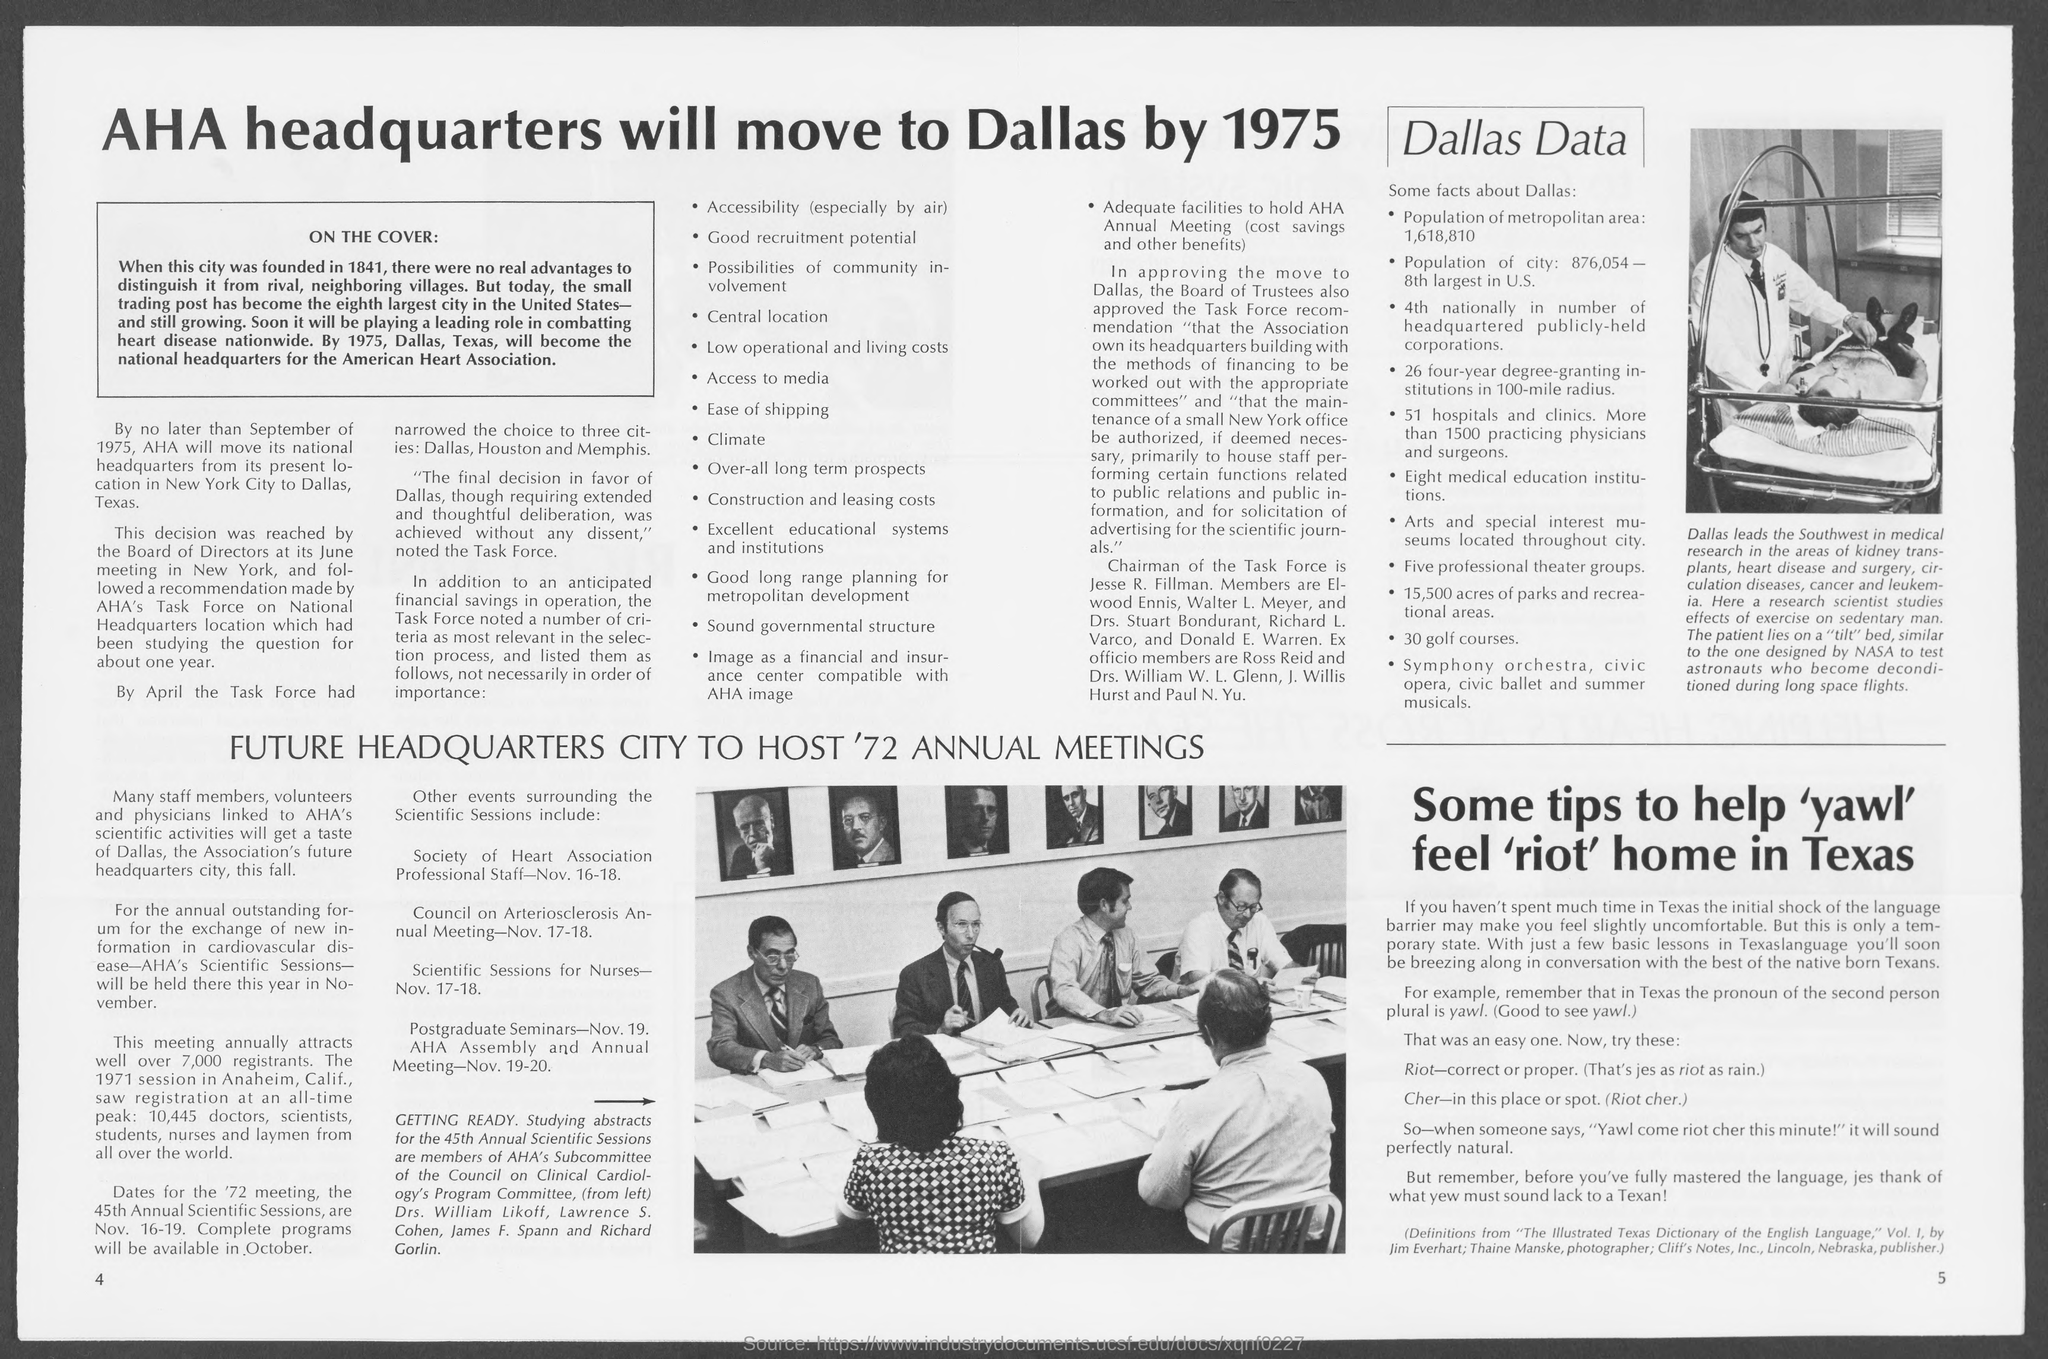Outline some significant characteristics in this image. The number on the bottom left page is 4. The number at the bottom right page is 5. 